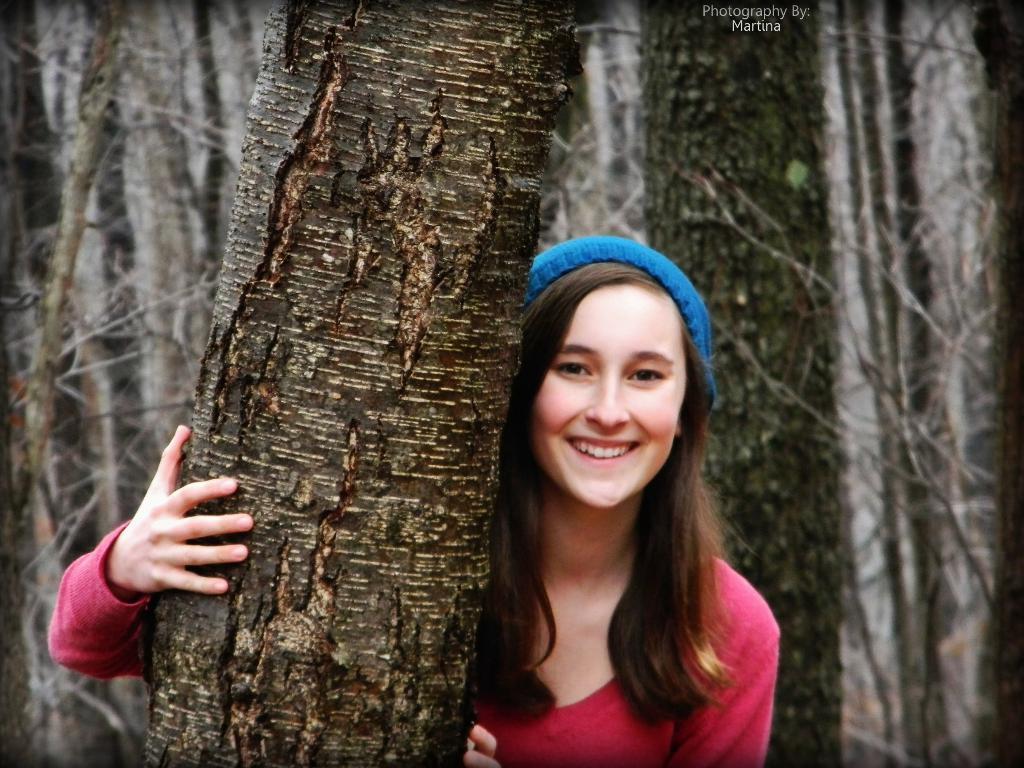Please provide a concise description of this image. There is a woman smiling and wore cap. We can see trees. At the top we can see text. 